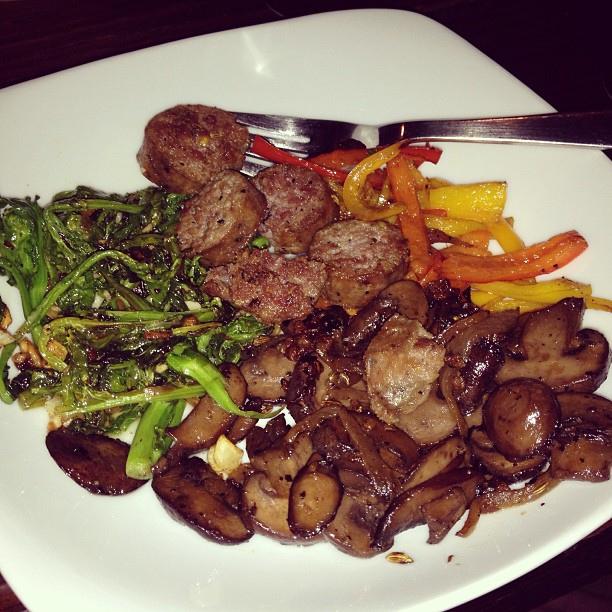What color is the plate the food is on?
Keep it brief. White. What kind of meat is on the plate?
Be succinct. Sausage. What type of vegetables are on the plate?
Answer briefly. Asparagus. 